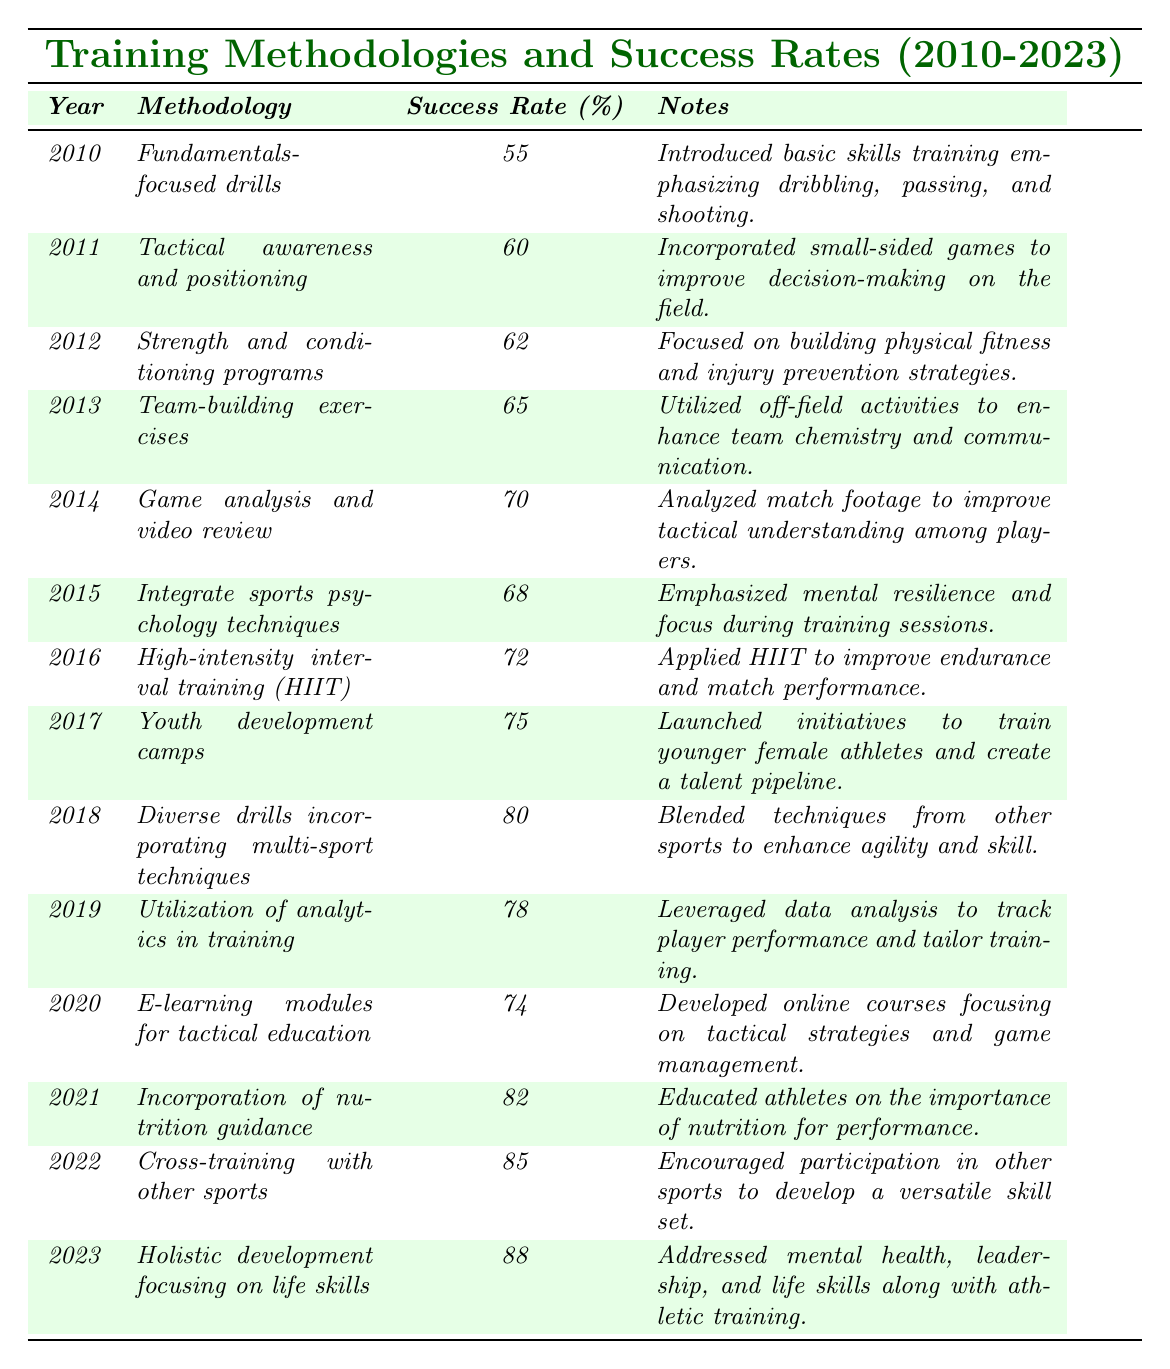What was the success rate for training methodologies in 2015? From the table, the success rate for the training methodology in 2015, which is "Integrate sports psychology techniques," is 68%.
Answer: 68% Which training methodology had the highest success rate, and what year was it? The highest success rate is 88%, associated with the "Holistic development focusing on life skills" methodology in the year 2023.
Answer: 88%, 2023 What is the average success rate for training methodologies from 2010 to 2014? The success rates for 2010 to 2014 are 55%, 60%, 62%, 65%, and 70%. Summing these gives 55 + 60 + 62 + 65 + 70 = 312. There are 5 data points, so the average is 312 / 5 = 62.4%.
Answer: 62.4% Did the success rate improve every year from 2010 to 2023? Reviewing the success rates from the table, we see that there were fluctuations; specifically, there was a decrease from 70% in 2014 to 68% in 2015. Thus, the success rate did not improve every year.
Answer: No What was the increase in success rate from 2011 to 2021? The success rate in 2011 was 60%, and in 2021 it was 82%. The increase is 82 - 60 = 22%.
Answer: 22% Which two years had the closest success rates and what were those rates? The years 2020 and 2019 had the closest success rates of 74% and 78%, respectively. The difference is only 4%.
Answer: 74% and 78% What proportion of training methodologies from 2015 to 2023 had success rates above 70%? The success rates from 2015 to 2023 are 68%, 72%, 75%, 80%, 78%, 74%, 82%, 85%, and 88%. The years with rates above 70% are 72%, 75%, 80%, 78%, 82%, 85%, and 88%, which is 7 out of 9 methodologies. Therefore, the proportion is 7/9 = 0.777 or about 77.7%.
Answer: ~77.7% What method introduced in 2014 had a higher success rate than team-building exercises in 2013? The "Game analysis and video review" method introduced in 2014 had a success rate of 70%, which is higher than the 65% from the team-building exercises in 2013.
Answer: Yes What is the change in the success rate from 2012 to 2023? The success rate in 2012 was 62%, and in 2023 it was 88%. The change is 88 - 62 = 26%.
Answer: 26% 